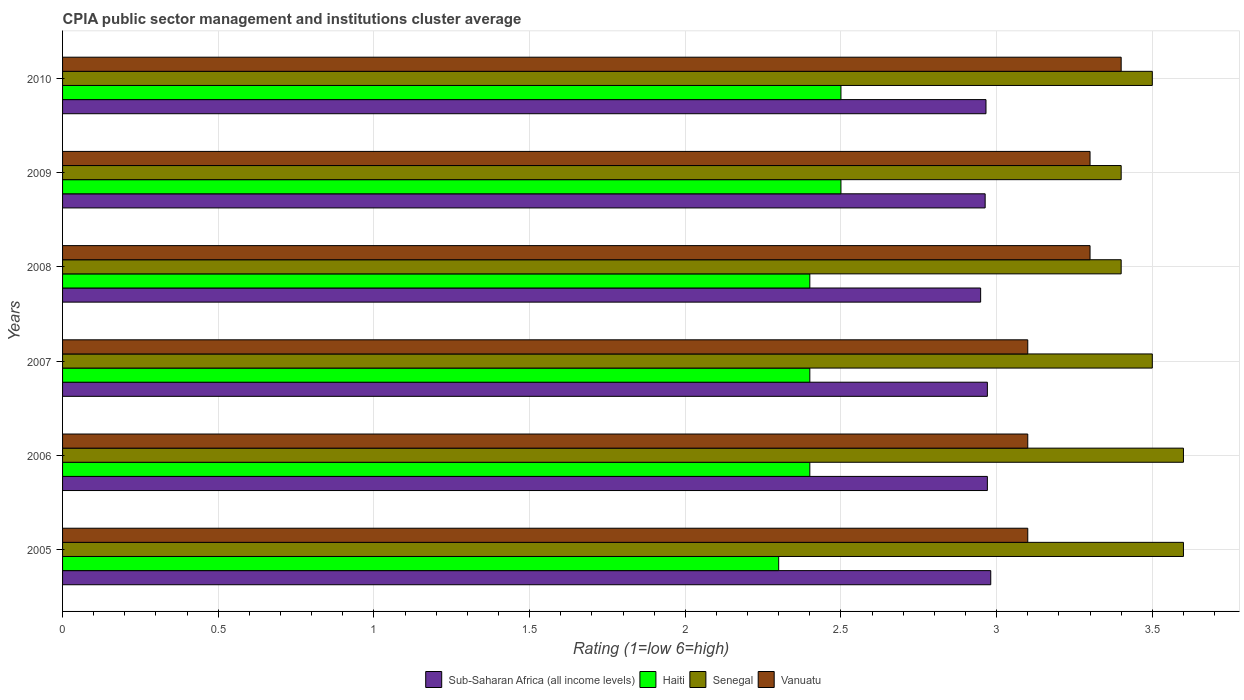How many bars are there on the 4th tick from the top?
Your answer should be very brief. 4. How many bars are there on the 2nd tick from the bottom?
Your answer should be compact. 4. In how many cases, is the number of bars for a given year not equal to the number of legend labels?
Provide a short and direct response. 0. What is the CPIA rating in Haiti in 2010?
Your answer should be compact. 2.5. Across all years, what is the maximum CPIA rating in Sub-Saharan Africa (all income levels)?
Make the answer very short. 2.98. Across all years, what is the minimum CPIA rating in Senegal?
Give a very brief answer. 3.4. In which year was the CPIA rating in Sub-Saharan Africa (all income levels) maximum?
Make the answer very short. 2005. What is the total CPIA rating in Vanuatu in the graph?
Your answer should be very brief. 19.3. What is the difference between the CPIA rating in Vanuatu in 2010 and the CPIA rating in Sub-Saharan Africa (all income levels) in 2008?
Your response must be concise. 0.45. What is the average CPIA rating in Sub-Saharan Africa (all income levels) per year?
Provide a succinct answer. 2.97. In the year 2008, what is the difference between the CPIA rating in Sub-Saharan Africa (all income levels) and CPIA rating in Haiti?
Make the answer very short. 0.55. Is the CPIA rating in Sub-Saharan Africa (all income levels) in 2008 less than that in 2010?
Your answer should be compact. Yes. Is the difference between the CPIA rating in Sub-Saharan Africa (all income levels) in 2005 and 2007 greater than the difference between the CPIA rating in Haiti in 2005 and 2007?
Offer a very short reply. Yes. What is the difference between the highest and the second highest CPIA rating in Senegal?
Your answer should be compact. 0. What is the difference between the highest and the lowest CPIA rating in Haiti?
Ensure brevity in your answer.  0.2. Is the sum of the CPIA rating in Senegal in 2009 and 2010 greater than the maximum CPIA rating in Sub-Saharan Africa (all income levels) across all years?
Give a very brief answer. Yes. Is it the case that in every year, the sum of the CPIA rating in Haiti and CPIA rating in Senegal is greater than the sum of CPIA rating in Sub-Saharan Africa (all income levels) and CPIA rating in Vanuatu?
Ensure brevity in your answer.  Yes. What does the 2nd bar from the top in 2009 represents?
Keep it short and to the point. Senegal. What does the 1st bar from the bottom in 2007 represents?
Your answer should be very brief. Sub-Saharan Africa (all income levels). Is it the case that in every year, the sum of the CPIA rating in Sub-Saharan Africa (all income levels) and CPIA rating in Vanuatu is greater than the CPIA rating in Senegal?
Your response must be concise. Yes. How many bars are there?
Make the answer very short. 24. What is the difference between two consecutive major ticks on the X-axis?
Ensure brevity in your answer.  0.5. Does the graph contain grids?
Your response must be concise. Yes. Where does the legend appear in the graph?
Your response must be concise. Bottom center. What is the title of the graph?
Ensure brevity in your answer.  CPIA public sector management and institutions cluster average. Does "Morocco" appear as one of the legend labels in the graph?
Provide a succinct answer. No. What is the Rating (1=low 6=high) in Sub-Saharan Africa (all income levels) in 2005?
Make the answer very short. 2.98. What is the Rating (1=low 6=high) of Haiti in 2005?
Your answer should be very brief. 2.3. What is the Rating (1=low 6=high) of Sub-Saharan Africa (all income levels) in 2006?
Your answer should be compact. 2.97. What is the Rating (1=low 6=high) of Haiti in 2006?
Give a very brief answer. 2.4. What is the Rating (1=low 6=high) in Vanuatu in 2006?
Your answer should be very brief. 3.1. What is the Rating (1=low 6=high) of Sub-Saharan Africa (all income levels) in 2007?
Provide a succinct answer. 2.97. What is the Rating (1=low 6=high) in Haiti in 2007?
Give a very brief answer. 2.4. What is the Rating (1=low 6=high) of Senegal in 2007?
Offer a very short reply. 3.5. What is the Rating (1=low 6=high) in Sub-Saharan Africa (all income levels) in 2008?
Make the answer very short. 2.95. What is the Rating (1=low 6=high) in Sub-Saharan Africa (all income levels) in 2009?
Your answer should be very brief. 2.96. What is the Rating (1=low 6=high) of Haiti in 2009?
Provide a short and direct response. 2.5. What is the Rating (1=low 6=high) of Senegal in 2009?
Your answer should be compact. 3.4. What is the Rating (1=low 6=high) in Sub-Saharan Africa (all income levels) in 2010?
Your answer should be compact. 2.97. What is the Rating (1=low 6=high) of Haiti in 2010?
Offer a very short reply. 2.5. What is the Rating (1=low 6=high) in Vanuatu in 2010?
Your answer should be compact. 3.4. Across all years, what is the maximum Rating (1=low 6=high) in Sub-Saharan Africa (all income levels)?
Your answer should be very brief. 2.98. Across all years, what is the maximum Rating (1=low 6=high) in Haiti?
Your answer should be very brief. 2.5. Across all years, what is the maximum Rating (1=low 6=high) of Senegal?
Make the answer very short. 3.6. Across all years, what is the minimum Rating (1=low 6=high) in Sub-Saharan Africa (all income levels)?
Offer a terse response. 2.95. Across all years, what is the minimum Rating (1=low 6=high) of Haiti?
Keep it short and to the point. 2.3. Across all years, what is the minimum Rating (1=low 6=high) of Senegal?
Give a very brief answer. 3.4. Across all years, what is the minimum Rating (1=low 6=high) in Vanuatu?
Your response must be concise. 3.1. What is the total Rating (1=low 6=high) in Sub-Saharan Africa (all income levels) in the graph?
Offer a terse response. 17.8. What is the total Rating (1=low 6=high) of Haiti in the graph?
Your response must be concise. 14.5. What is the total Rating (1=low 6=high) of Vanuatu in the graph?
Offer a terse response. 19.3. What is the difference between the Rating (1=low 6=high) in Sub-Saharan Africa (all income levels) in 2005 and that in 2006?
Keep it short and to the point. 0.01. What is the difference between the Rating (1=low 6=high) in Haiti in 2005 and that in 2006?
Your answer should be compact. -0.1. What is the difference between the Rating (1=low 6=high) of Vanuatu in 2005 and that in 2006?
Offer a very short reply. 0. What is the difference between the Rating (1=low 6=high) of Sub-Saharan Africa (all income levels) in 2005 and that in 2007?
Ensure brevity in your answer.  0.01. What is the difference between the Rating (1=low 6=high) in Haiti in 2005 and that in 2007?
Your answer should be compact. -0.1. What is the difference between the Rating (1=low 6=high) of Vanuatu in 2005 and that in 2007?
Make the answer very short. 0. What is the difference between the Rating (1=low 6=high) of Sub-Saharan Africa (all income levels) in 2005 and that in 2008?
Make the answer very short. 0.03. What is the difference between the Rating (1=low 6=high) in Sub-Saharan Africa (all income levels) in 2005 and that in 2009?
Offer a terse response. 0.02. What is the difference between the Rating (1=low 6=high) of Haiti in 2005 and that in 2009?
Keep it short and to the point. -0.2. What is the difference between the Rating (1=low 6=high) of Senegal in 2005 and that in 2009?
Your response must be concise. 0.2. What is the difference between the Rating (1=low 6=high) of Sub-Saharan Africa (all income levels) in 2005 and that in 2010?
Ensure brevity in your answer.  0.02. What is the difference between the Rating (1=low 6=high) of Sub-Saharan Africa (all income levels) in 2006 and that in 2007?
Offer a very short reply. 0. What is the difference between the Rating (1=low 6=high) in Senegal in 2006 and that in 2007?
Keep it short and to the point. 0.1. What is the difference between the Rating (1=low 6=high) of Vanuatu in 2006 and that in 2007?
Give a very brief answer. 0. What is the difference between the Rating (1=low 6=high) in Sub-Saharan Africa (all income levels) in 2006 and that in 2008?
Keep it short and to the point. 0.02. What is the difference between the Rating (1=low 6=high) of Haiti in 2006 and that in 2008?
Give a very brief answer. 0. What is the difference between the Rating (1=low 6=high) of Senegal in 2006 and that in 2008?
Ensure brevity in your answer.  0.2. What is the difference between the Rating (1=low 6=high) of Sub-Saharan Africa (all income levels) in 2006 and that in 2009?
Your answer should be compact. 0.01. What is the difference between the Rating (1=low 6=high) of Senegal in 2006 and that in 2009?
Ensure brevity in your answer.  0.2. What is the difference between the Rating (1=low 6=high) of Vanuatu in 2006 and that in 2009?
Your answer should be compact. -0.2. What is the difference between the Rating (1=low 6=high) of Sub-Saharan Africa (all income levels) in 2006 and that in 2010?
Ensure brevity in your answer.  0. What is the difference between the Rating (1=low 6=high) in Senegal in 2006 and that in 2010?
Keep it short and to the point. 0.1. What is the difference between the Rating (1=low 6=high) in Vanuatu in 2006 and that in 2010?
Provide a succinct answer. -0.3. What is the difference between the Rating (1=low 6=high) of Sub-Saharan Africa (all income levels) in 2007 and that in 2008?
Provide a succinct answer. 0.02. What is the difference between the Rating (1=low 6=high) of Haiti in 2007 and that in 2008?
Offer a terse response. 0. What is the difference between the Rating (1=low 6=high) in Senegal in 2007 and that in 2008?
Keep it short and to the point. 0.1. What is the difference between the Rating (1=low 6=high) in Vanuatu in 2007 and that in 2008?
Ensure brevity in your answer.  -0.2. What is the difference between the Rating (1=low 6=high) of Sub-Saharan Africa (all income levels) in 2007 and that in 2009?
Make the answer very short. 0.01. What is the difference between the Rating (1=low 6=high) of Haiti in 2007 and that in 2009?
Provide a succinct answer. -0.1. What is the difference between the Rating (1=low 6=high) in Vanuatu in 2007 and that in 2009?
Give a very brief answer. -0.2. What is the difference between the Rating (1=low 6=high) of Sub-Saharan Africa (all income levels) in 2007 and that in 2010?
Your response must be concise. 0. What is the difference between the Rating (1=low 6=high) in Haiti in 2007 and that in 2010?
Your response must be concise. -0.1. What is the difference between the Rating (1=low 6=high) in Vanuatu in 2007 and that in 2010?
Give a very brief answer. -0.3. What is the difference between the Rating (1=low 6=high) of Sub-Saharan Africa (all income levels) in 2008 and that in 2009?
Provide a succinct answer. -0.01. What is the difference between the Rating (1=low 6=high) of Sub-Saharan Africa (all income levels) in 2008 and that in 2010?
Give a very brief answer. -0.02. What is the difference between the Rating (1=low 6=high) in Sub-Saharan Africa (all income levels) in 2009 and that in 2010?
Your response must be concise. -0. What is the difference between the Rating (1=low 6=high) in Haiti in 2009 and that in 2010?
Give a very brief answer. 0. What is the difference between the Rating (1=low 6=high) of Senegal in 2009 and that in 2010?
Keep it short and to the point. -0.1. What is the difference between the Rating (1=low 6=high) of Sub-Saharan Africa (all income levels) in 2005 and the Rating (1=low 6=high) of Haiti in 2006?
Your answer should be compact. 0.58. What is the difference between the Rating (1=low 6=high) in Sub-Saharan Africa (all income levels) in 2005 and the Rating (1=low 6=high) in Senegal in 2006?
Provide a succinct answer. -0.62. What is the difference between the Rating (1=low 6=high) of Sub-Saharan Africa (all income levels) in 2005 and the Rating (1=low 6=high) of Vanuatu in 2006?
Give a very brief answer. -0.12. What is the difference between the Rating (1=low 6=high) of Senegal in 2005 and the Rating (1=low 6=high) of Vanuatu in 2006?
Offer a terse response. 0.5. What is the difference between the Rating (1=low 6=high) in Sub-Saharan Africa (all income levels) in 2005 and the Rating (1=low 6=high) in Haiti in 2007?
Give a very brief answer. 0.58. What is the difference between the Rating (1=low 6=high) in Sub-Saharan Africa (all income levels) in 2005 and the Rating (1=low 6=high) in Senegal in 2007?
Offer a very short reply. -0.52. What is the difference between the Rating (1=low 6=high) of Sub-Saharan Africa (all income levels) in 2005 and the Rating (1=low 6=high) of Vanuatu in 2007?
Make the answer very short. -0.12. What is the difference between the Rating (1=low 6=high) in Sub-Saharan Africa (all income levels) in 2005 and the Rating (1=low 6=high) in Haiti in 2008?
Provide a short and direct response. 0.58. What is the difference between the Rating (1=low 6=high) of Sub-Saharan Africa (all income levels) in 2005 and the Rating (1=low 6=high) of Senegal in 2008?
Make the answer very short. -0.42. What is the difference between the Rating (1=low 6=high) in Sub-Saharan Africa (all income levels) in 2005 and the Rating (1=low 6=high) in Vanuatu in 2008?
Provide a short and direct response. -0.32. What is the difference between the Rating (1=low 6=high) of Senegal in 2005 and the Rating (1=low 6=high) of Vanuatu in 2008?
Ensure brevity in your answer.  0.3. What is the difference between the Rating (1=low 6=high) of Sub-Saharan Africa (all income levels) in 2005 and the Rating (1=low 6=high) of Haiti in 2009?
Offer a very short reply. 0.48. What is the difference between the Rating (1=low 6=high) in Sub-Saharan Africa (all income levels) in 2005 and the Rating (1=low 6=high) in Senegal in 2009?
Give a very brief answer. -0.42. What is the difference between the Rating (1=low 6=high) of Sub-Saharan Africa (all income levels) in 2005 and the Rating (1=low 6=high) of Vanuatu in 2009?
Your answer should be compact. -0.32. What is the difference between the Rating (1=low 6=high) in Haiti in 2005 and the Rating (1=low 6=high) in Vanuatu in 2009?
Keep it short and to the point. -1. What is the difference between the Rating (1=low 6=high) in Sub-Saharan Africa (all income levels) in 2005 and the Rating (1=low 6=high) in Haiti in 2010?
Your answer should be compact. 0.48. What is the difference between the Rating (1=low 6=high) in Sub-Saharan Africa (all income levels) in 2005 and the Rating (1=low 6=high) in Senegal in 2010?
Your answer should be compact. -0.52. What is the difference between the Rating (1=low 6=high) of Sub-Saharan Africa (all income levels) in 2005 and the Rating (1=low 6=high) of Vanuatu in 2010?
Ensure brevity in your answer.  -0.42. What is the difference between the Rating (1=low 6=high) of Senegal in 2005 and the Rating (1=low 6=high) of Vanuatu in 2010?
Your answer should be very brief. 0.2. What is the difference between the Rating (1=low 6=high) in Sub-Saharan Africa (all income levels) in 2006 and the Rating (1=low 6=high) in Haiti in 2007?
Offer a very short reply. 0.57. What is the difference between the Rating (1=low 6=high) in Sub-Saharan Africa (all income levels) in 2006 and the Rating (1=low 6=high) in Senegal in 2007?
Give a very brief answer. -0.53. What is the difference between the Rating (1=low 6=high) in Sub-Saharan Africa (all income levels) in 2006 and the Rating (1=low 6=high) in Vanuatu in 2007?
Keep it short and to the point. -0.13. What is the difference between the Rating (1=low 6=high) in Haiti in 2006 and the Rating (1=low 6=high) in Senegal in 2007?
Your response must be concise. -1.1. What is the difference between the Rating (1=low 6=high) in Haiti in 2006 and the Rating (1=low 6=high) in Vanuatu in 2007?
Provide a short and direct response. -0.7. What is the difference between the Rating (1=low 6=high) in Sub-Saharan Africa (all income levels) in 2006 and the Rating (1=low 6=high) in Haiti in 2008?
Your answer should be very brief. 0.57. What is the difference between the Rating (1=low 6=high) in Sub-Saharan Africa (all income levels) in 2006 and the Rating (1=low 6=high) in Senegal in 2008?
Provide a short and direct response. -0.43. What is the difference between the Rating (1=low 6=high) in Sub-Saharan Africa (all income levels) in 2006 and the Rating (1=low 6=high) in Vanuatu in 2008?
Your answer should be compact. -0.33. What is the difference between the Rating (1=low 6=high) of Haiti in 2006 and the Rating (1=low 6=high) of Senegal in 2008?
Offer a terse response. -1. What is the difference between the Rating (1=low 6=high) of Senegal in 2006 and the Rating (1=low 6=high) of Vanuatu in 2008?
Provide a succinct answer. 0.3. What is the difference between the Rating (1=low 6=high) in Sub-Saharan Africa (all income levels) in 2006 and the Rating (1=low 6=high) in Haiti in 2009?
Give a very brief answer. 0.47. What is the difference between the Rating (1=low 6=high) of Sub-Saharan Africa (all income levels) in 2006 and the Rating (1=low 6=high) of Senegal in 2009?
Your answer should be very brief. -0.43. What is the difference between the Rating (1=low 6=high) of Sub-Saharan Africa (all income levels) in 2006 and the Rating (1=low 6=high) of Vanuatu in 2009?
Your answer should be very brief. -0.33. What is the difference between the Rating (1=low 6=high) of Haiti in 2006 and the Rating (1=low 6=high) of Vanuatu in 2009?
Offer a very short reply. -0.9. What is the difference between the Rating (1=low 6=high) in Senegal in 2006 and the Rating (1=low 6=high) in Vanuatu in 2009?
Your answer should be very brief. 0.3. What is the difference between the Rating (1=low 6=high) of Sub-Saharan Africa (all income levels) in 2006 and the Rating (1=low 6=high) of Haiti in 2010?
Your answer should be compact. 0.47. What is the difference between the Rating (1=low 6=high) of Sub-Saharan Africa (all income levels) in 2006 and the Rating (1=low 6=high) of Senegal in 2010?
Offer a terse response. -0.53. What is the difference between the Rating (1=low 6=high) in Sub-Saharan Africa (all income levels) in 2006 and the Rating (1=low 6=high) in Vanuatu in 2010?
Your response must be concise. -0.43. What is the difference between the Rating (1=low 6=high) of Haiti in 2006 and the Rating (1=low 6=high) of Senegal in 2010?
Your response must be concise. -1.1. What is the difference between the Rating (1=low 6=high) of Haiti in 2006 and the Rating (1=low 6=high) of Vanuatu in 2010?
Keep it short and to the point. -1. What is the difference between the Rating (1=low 6=high) of Senegal in 2006 and the Rating (1=low 6=high) of Vanuatu in 2010?
Keep it short and to the point. 0.2. What is the difference between the Rating (1=low 6=high) in Sub-Saharan Africa (all income levels) in 2007 and the Rating (1=low 6=high) in Haiti in 2008?
Offer a very short reply. 0.57. What is the difference between the Rating (1=low 6=high) in Sub-Saharan Africa (all income levels) in 2007 and the Rating (1=low 6=high) in Senegal in 2008?
Give a very brief answer. -0.43. What is the difference between the Rating (1=low 6=high) of Sub-Saharan Africa (all income levels) in 2007 and the Rating (1=low 6=high) of Vanuatu in 2008?
Ensure brevity in your answer.  -0.33. What is the difference between the Rating (1=low 6=high) of Haiti in 2007 and the Rating (1=low 6=high) of Vanuatu in 2008?
Offer a terse response. -0.9. What is the difference between the Rating (1=low 6=high) in Senegal in 2007 and the Rating (1=low 6=high) in Vanuatu in 2008?
Provide a short and direct response. 0.2. What is the difference between the Rating (1=low 6=high) of Sub-Saharan Africa (all income levels) in 2007 and the Rating (1=low 6=high) of Haiti in 2009?
Your response must be concise. 0.47. What is the difference between the Rating (1=low 6=high) in Sub-Saharan Africa (all income levels) in 2007 and the Rating (1=low 6=high) in Senegal in 2009?
Make the answer very short. -0.43. What is the difference between the Rating (1=low 6=high) in Sub-Saharan Africa (all income levels) in 2007 and the Rating (1=low 6=high) in Vanuatu in 2009?
Provide a succinct answer. -0.33. What is the difference between the Rating (1=low 6=high) of Sub-Saharan Africa (all income levels) in 2007 and the Rating (1=low 6=high) of Haiti in 2010?
Provide a succinct answer. 0.47. What is the difference between the Rating (1=low 6=high) in Sub-Saharan Africa (all income levels) in 2007 and the Rating (1=low 6=high) in Senegal in 2010?
Keep it short and to the point. -0.53. What is the difference between the Rating (1=low 6=high) of Sub-Saharan Africa (all income levels) in 2007 and the Rating (1=low 6=high) of Vanuatu in 2010?
Give a very brief answer. -0.43. What is the difference between the Rating (1=low 6=high) of Haiti in 2007 and the Rating (1=low 6=high) of Senegal in 2010?
Give a very brief answer. -1.1. What is the difference between the Rating (1=low 6=high) in Senegal in 2007 and the Rating (1=low 6=high) in Vanuatu in 2010?
Offer a terse response. 0.1. What is the difference between the Rating (1=low 6=high) of Sub-Saharan Africa (all income levels) in 2008 and the Rating (1=low 6=high) of Haiti in 2009?
Your response must be concise. 0.45. What is the difference between the Rating (1=low 6=high) of Sub-Saharan Africa (all income levels) in 2008 and the Rating (1=low 6=high) of Senegal in 2009?
Your answer should be compact. -0.45. What is the difference between the Rating (1=low 6=high) of Sub-Saharan Africa (all income levels) in 2008 and the Rating (1=low 6=high) of Vanuatu in 2009?
Provide a short and direct response. -0.35. What is the difference between the Rating (1=low 6=high) of Haiti in 2008 and the Rating (1=low 6=high) of Vanuatu in 2009?
Offer a very short reply. -0.9. What is the difference between the Rating (1=low 6=high) of Senegal in 2008 and the Rating (1=low 6=high) of Vanuatu in 2009?
Offer a terse response. 0.1. What is the difference between the Rating (1=low 6=high) in Sub-Saharan Africa (all income levels) in 2008 and the Rating (1=low 6=high) in Haiti in 2010?
Offer a very short reply. 0.45. What is the difference between the Rating (1=low 6=high) in Sub-Saharan Africa (all income levels) in 2008 and the Rating (1=low 6=high) in Senegal in 2010?
Offer a very short reply. -0.55. What is the difference between the Rating (1=low 6=high) of Sub-Saharan Africa (all income levels) in 2008 and the Rating (1=low 6=high) of Vanuatu in 2010?
Keep it short and to the point. -0.45. What is the difference between the Rating (1=low 6=high) of Haiti in 2008 and the Rating (1=low 6=high) of Senegal in 2010?
Ensure brevity in your answer.  -1.1. What is the difference between the Rating (1=low 6=high) of Haiti in 2008 and the Rating (1=low 6=high) of Vanuatu in 2010?
Provide a short and direct response. -1. What is the difference between the Rating (1=low 6=high) of Sub-Saharan Africa (all income levels) in 2009 and the Rating (1=low 6=high) of Haiti in 2010?
Your response must be concise. 0.46. What is the difference between the Rating (1=low 6=high) in Sub-Saharan Africa (all income levels) in 2009 and the Rating (1=low 6=high) in Senegal in 2010?
Keep it short and to the point. -0.54. What is the difference between the Rating (1=low 6=high) in Sub-Saharan Africa (all income levels) in 2009 and the Rating (1=low 6=high) in Vanuatu in 2010?
Give a very brief answer. -0.44. What is the difference between the Rating (1=low 6=high) in Haiti in 2009 and the Rating (1=low 6=high) in Senegal in 2010?
Your response must be concise. -1. What is the difference between the Rating (1=low 6=high) of Haiti in 2009 and the Rating (1=low 6=high) of Vanuatu in 2010?
Offer a very short reply. -0.9. What is the difference between the Rating (1=low 6=high) of Senegal in 2009 and the Rating (1=low 6=high) of Vanuatu in 2010?
Ensure brevity in your answer.  0. What is the average Rating (1=low 6=high) in Sub-Saharan Africa (all income levels) per year?
Your answer should be very brief. 2.97. What is the average Rating (1=low 6=high) in Haiti per year?
Give a very brief answer. 2.42. What is the average Rating (1=low 6=high) in Vanuatu per year?
Ensure brevity in your answer.  3.22. In the year 2005, what is the difference between the Rating (1=low 6=high) of Sub-Saharan Africa (all income levels) and Rating (1=low 6=high) of Haiti?
Your answer should be very brief. 0.68. In the year 2005, what is the difference between the Rating (1=low 6=high) in Sub-Saharan Africa (all income levels) and Rating (1=low 6=high) in Senegal?
Provide a short and direct response. -0.62. In the year 2005, what is the difference between the Rating (1=low 6=high) of Sub-Saharan Africa (all income levels) and Rating (1=low 6=high) of Vanuatu?
Your answer should be compact. -0.12. In the year 2005, what is the difference between the Rating (1=low 6=high) in Haiti and Rating (1=low 6=high) in Senegal?
Keep it short and to the point. -1.3. In the year 2005, what is the difference between the Rating (1=low 6=high) in Haiti and Rating (1=low 6=high) in Vanuatu?
Your answer should be very brief. -0.8. In the year 2005, what is the difference between the Rating (1=low 6=high) in Senegal and Rating (1=low 6=high) in Vanuatu?
Your response must be concise. 0.5. In the year 2006, what is the difference between the Rating (1=low 6=high) of Sub-Saharan Africa (all income levels) and Rating (1=low 6=high) of Haiti?
Provide a short and direct response. 0.57. In the year 2006, what is the difference between the Rating (1=low 6=high) in Sub-Saharan Africa (all income levels) and Rating (1=low 6=high) in Senegal?
Your response must be concise. -0.63. In the year 2006, what is the difference between the Rating (1=low 6=high) of Sub-Saharan Africa (all income levels) and Rating (1=low 6=high) of Vanuatu?
Provide a short and direct response. -0.13. In the year 2006, what is the difference between the Rating (1=low 6=high) in Haiti and Rating (1=low 6=high) in Vanuatu?
Ensure brevity in your answer.  -0.7. In the year 2006, what is the difference between the Rating (1=low 6=high) in Senegal and Rating (1=low 6=high) in Vanuatu?
Your response must be concise. 0.5. In the year 2007, what is the difference between the Rating (1=low 6=high) of Sub-Saharan Africa (all income levels) and Rating (1=low 6=high) of Haiti?
Make the answer very short. 0.57. In the year 2007, what is the difference between the Rating (1=low 6=high) of Sub-Saharan Africa (all income levels) and Rating (1=low 6=high) of Senegal?
Offer a terse response. -0.53. In the year 2007, what is the difference between the Rating (1=low 6=high) in Sub-Saharan Africa (all income levels) and Rating (1=low 6=high) in Vanuatu?
Your answer should be compact. -0.13. In the year 2007, what is the difference between the Rating (1=low 6=high) of Haiti and Rating (1=low 6=high) of Senegal?
Your answer should be very brief. -1.1. In the year 2007, what is the difference between the Rating (1=low 6=high) in Senegal and Rating (1=low 6=high) in Vanuatu?
Make the answer very short. 0.4. In the year 2008, what is the difference between the Rating (1=low 6=high) in Sub-Saharan Africa (all income levels) and Rating (1=low 6=high) in Haiti?
Your answer should be compact. 0.55. In the year 2008, what is the difference between the Rating (1=low 6=high) in Sub-Saharan Africa (all income levels) and Rating (1=low 6=high) in Senegal?
Make the answer very short. -0.45. In the year 2008, what is the difference between the Rating (1=low 6=high) in Sub-Saharan Africa (all income levels) and Rating (1=low 6=high) in Vanuatu?
Your answer should be compact. -0.35. In the year 2008, what is the difference between the Rating (1=low 6=high) of Senegal and Rating (1=low 6=high) of Vanuatu?
Keep it short and to the point. 0.1. In the year 2009, what is the difference between the Rating (1=low 6=high) of Sub-Saharan Africa (all income levels) and Rating (1=low 6=high) of Haiti?
Offer a terse response. 0.46. In the year 2009, what is the difference between the Rating (1=low 6=high) of Sub-Saharan Africa (all income levels) and Rating (1=low 6=high) of Senegal?
Give a very brief answer. -0.44. In the year 2009, what is the difference between the Rating (1=low 6=high) in Sub-Saharan Africa (all income levels) and Rating (1=low 6=high) in Vanuatu?
Offer a terse response. -0.34. In the year 2009, what is the difference between the Rating (1=low 6=high) of Haiti and Rating (1=low 6=high) of Vanuatu?
Ensure brevity in your answer.  -0.8. In the year 2010, what is the difference between the Rating (1=low 6=high) in Sub-Saharan Africa (all income levels) and Rating (1=low 6=high) in Haiti?
Make the answer very short. 0.47. In the year 2010, what is the difference between the Rating (1=low 6=high) of Sub-Saharan Africa (all income levels) and Rating (1=low 6=high) of Senegal?
Offer a terse response. -0.53. In the year 2010, what is the difference between the Rating (1=low 6=high) in Sub-Saharan Africa (all income levels) and Rating (1=low 6=high) in Vanuatu?
Make the answer very short. -0.43. In the year 2010, what is the difference between the Rating (1=low 6=high) of Haiti and Rating (1=low 6=high) of Senegal?
Provide a short and direct response. -1. In the year 2010, what is the difference between the Rating (1=low 6=high) of Senegal and Rating (1=low 6=high) of Vanuatu?
Provide a short and direct response. 0.1. What is the ratio of the Rating (1=low 6=high) of Senegal in 2005 to that in 2006?
Provide a short and direct response. 1. What is the ratio of the Rating (1=low 6=high) of Haiti in 2005 to that in 2007?
Your answer should be compact. 0.96. What is the ratio of the Rating (1=low 6=high) of Senegal in 2005 to that in 2007?
Offer a very short reply. 1.03. What is the ratio of the Rating (1=low 6=high) in Sub-Saharan Africa (all income levels) in 2005 to that in 2008?
Keep it short and to the point. 1.01. What is the ratio of the Rating (1=low 6=high) in Haiti in 2005 to that in 2008?
Your answer should be very brief. 0.96. What is the ratio of the Rating (1=low 6=high) of Senegal in 2005 to that in 2008?
Your response must be concise. 1.06. What is the ratio of the Rating (1=low 6=high) of Vanuatu in 2005 to that in 2008?
Your response must be concise. 0.94. What is the ratio of the Rating (1=low 6=high) of Sub-Saharan Africa (all income levels) in 2005 to that in 2009?
Make the answer very short. 1.01. What is the ratio of the Rating (1=low 6=high) in Senegal in 2005 to that in 2009?
Make the answer very short. 1.06. What is the ratio of the Rating (1=low 6=high) of Vanuatu in 2005 to that in 2009?
Offer a terse response. 0.94. What is the ratio of the Rating (1=low 6=high) of Haiti in 2005 to that in 2010?
Provide a succinct answer. 0.92. What is the ratio of the Rating (1=low 6=high) in Senegal in 2005 to that in 2010?
Give a very brief answer. 1.03. What is the ratio of the Rating (1=low 6=high) in Vanuatu in 2005 to that in 2010?
Keep it short and to the point. 0.91. What is the ratio of the Rating (1=low 6=high) in Sub-Saharan Africa (all income levels) in 2006 to that in 2007?
Give a very brief answer. 1. What is the ratio of the Rating (1=low 6=high) in Senegal in 2006 to that in 2007?
Provide a short and direct response. 1.03. What is the ratio of the Rating (1=low 6=high) of Sub-Saharan Africa (all income levels) in 2006 to that in 2008?
Ensure brevity in your answer.  1.01. What is the ratio of the Rating (1=low 6=high) in Senegal in 2006 to that in 2008?
Your answer should be very brief. 1.06. What is the ratio of the Rating (1=low 6=high) in Vanuatu in 2006 to that in 2008?
Offer a terse response. 0.94. What is the ratio of the Rating (1=low 6=high) of Senegal in 2006 to that in 2009?
Provide a succinct answer. 1.06. What is the ratio of the Rating (1=low 6=high) in Vanuatu in 2006 to that in 2009?
Ensure brevity in your answer.  0.94. What is the ratio of the Rating (1=low 6=high) of Sub-Saharan Africa (all income levels) in 2006 to that in 2010?
Offer a terse response. 1. What is the ratio of the Rating (1=low 6=high) of Senegal in 2006 to that in 2010?
Your response must be concise. 1.03. What is the ratio of the Rating (1=low 6=high) of Vanuatu in 2006 to that in 2010?
Your answer should be compact. 0.91. What is the ratio of the Rating (1=low 6=high) of Sub-Saharan Africa (all income levels) in 2007 to that in 2008?
Offer a terse response. 1.01. What is the ratio of the Rating (1=low 6=high) in Senegal in 2007 to that in 2008?
Provide a short and direct response. 1.03. What is the ratio of the Rating (1=low 6=high) in Vanuatu in 2007 to that in 2008?
Make the answer very short. 0.94. What is the ratio of the Rating (1=low 6=high) of Sub-Saharan Africa (all income levels) in 2007 to that in 2009?
Give a very brief answer. 1. What is the ratio of the Rating (1=low 6=high) of Senegal in 2007 to that in 2009?
Keep it short and to the point. 1.03. What is the ratio of the Rating (1=low 6=high) of Vanuatu in 2007 to that in 2009?
Offer a very short reply. 0.94. What is the ratio of the Rating (1=low 6=high) of Senegal in 2007 to that in 2010?
Make the answer very short. 1. What is the ratio of the Rating (1=low 6=high) of Vanuatu in 2007 to that in 2010?
Your answer should be compact. 0.91. What is the ratio of the Rating (1=low 6=high) of Sub-Saharan Africa (all income levels) in 2008 to that in 2009?
Ensure brevity in your answer.  1. What is the ratio of the Rating (1=low 6=high) of Haiti in 2008 to that in 2009?
Provide a succinct answer. 0.96. What is the ratio of the Rating (1=low 6=high) of Senegal in 2008 to that in 2009?
Give a very brief answer. 1. What is the ratio of the Rating (1=low 6=high) in Senegal in 2008 to that in 2010?
Give a very brief answer. 0.97. What is the ratio of the Rating (1=low 6=high) in Vanuatu in 2008 to that in 2010?
Provide a short and direct response. 0.97. What is the ratio of the Rating (1=low 6=high) in Senegal in 2009 to that in 2010?
Your answer should be very brief. 0.97. What is the ratio of the Rating (1=low 6=high) in Vanuatu in 2009 to that in 2010?
Your answer should be compact. 0.97. What is the difference between the highest and the second highest Rating (1=low 6=high) of Sub-Saharan Africa (all income levels)?
Offer a very short reply. 0.01. What is the difference between the highest and the second highest Rating (1=low 6=high) in Haiti?
Offer a terse response. 0. What is the difference between the highest and the lowest Rating (1=low 6=high) in Sub-Saharan Africa (all income levels)?
Your answer should be very brief. 0.03. 